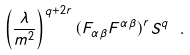<formula> <loc_0><loc_0><loc_500><loc_500>\left ( \frac { \lambda } { m ^ { 2 } } \right ) ^ { q + 2 r } ( F _ { \alpha \beta } F ^ { \alpha \beta } ) ^ { r } S ^ { q } \ .</formula> 